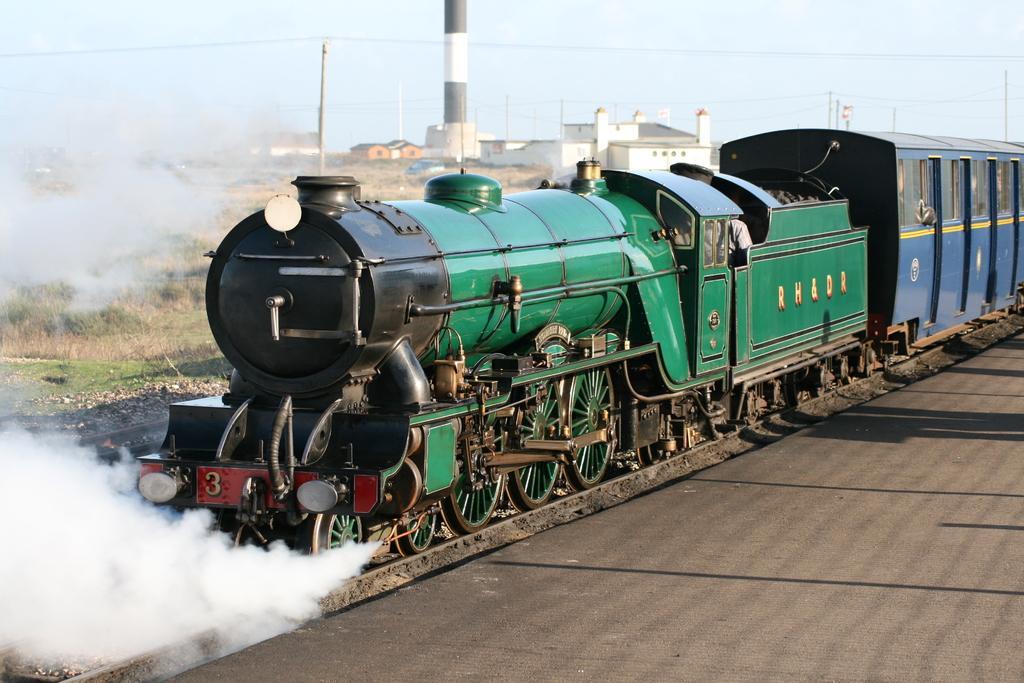In one or two sentences, can you explain what this image depicts? In this picture we can see a train on the railway track and in front of the track there is smoke and behind the train there is a factory, poles with cables, grass and a sky. 